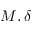Convert formula to latex. <formula><loc_0><loc_0><loc_500><loc_500>M , \delta</formula> 